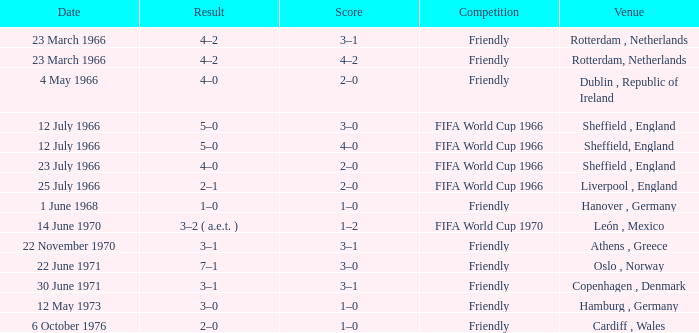Could you parse the entire table? {'header': ['Date', 'Result', 'Score', 'Competition', 'Venue'], 'rows': [['23 March 1966', '4–2', '3–1', 'Friendly', 'Rotterdam , Netherlands'], ['23 March 1966', '4–2', '4–2', 'Friendly', 'Rotterdam, Netherlands'], ['4 May 1966', '4–0', '2–0', 'Friendly', 'Dublin , Republic of Ireland'], ['12 July 1966', '5–0', '3–0', 'FIFA World Cup 1966', 'Sheffield , England'], ['12 July 1966', '5–0', '4–0', 'FIFA World Cup 1966', 'Sheffield, England'], ['23 July 1966', '4–0', '2–0', 'FIFA World Cup 1966', 'Sheffield , England'], ['25 July 1966', '2–1', '2–0', 'FIFA World Cup 1966', 'Liverpool , England'], ['1 June 1968', '1–0', '1–0', 'Friendly', 'Hanover , Germany'], ['14 June 1970', '3–2 ( a.e.t. )', '1–2', 'FIFA World Cup 1970', 'León , Mexico'], ['22 November 1970', '3–1', '3–1', 'Friendly', 'Athens , Greece'], ['22 June 1971', '7–1', '3–0', 'Friendly', 'Oslo , Norway'], ['30 June 1971', '3–1', '3–1', 'Friendly', 'Copenhagen , Denmark'], ['12 May 1973', '3–0', '1–0', 'Friendly', 'Hamburg , Germany'], ['6 October 1976', '2–0', '1–0', 'Friendly', 'Cardiff , Wales']]} Which result's venue was in Rotterdam, Netherlands? 4–2, 4–2. 